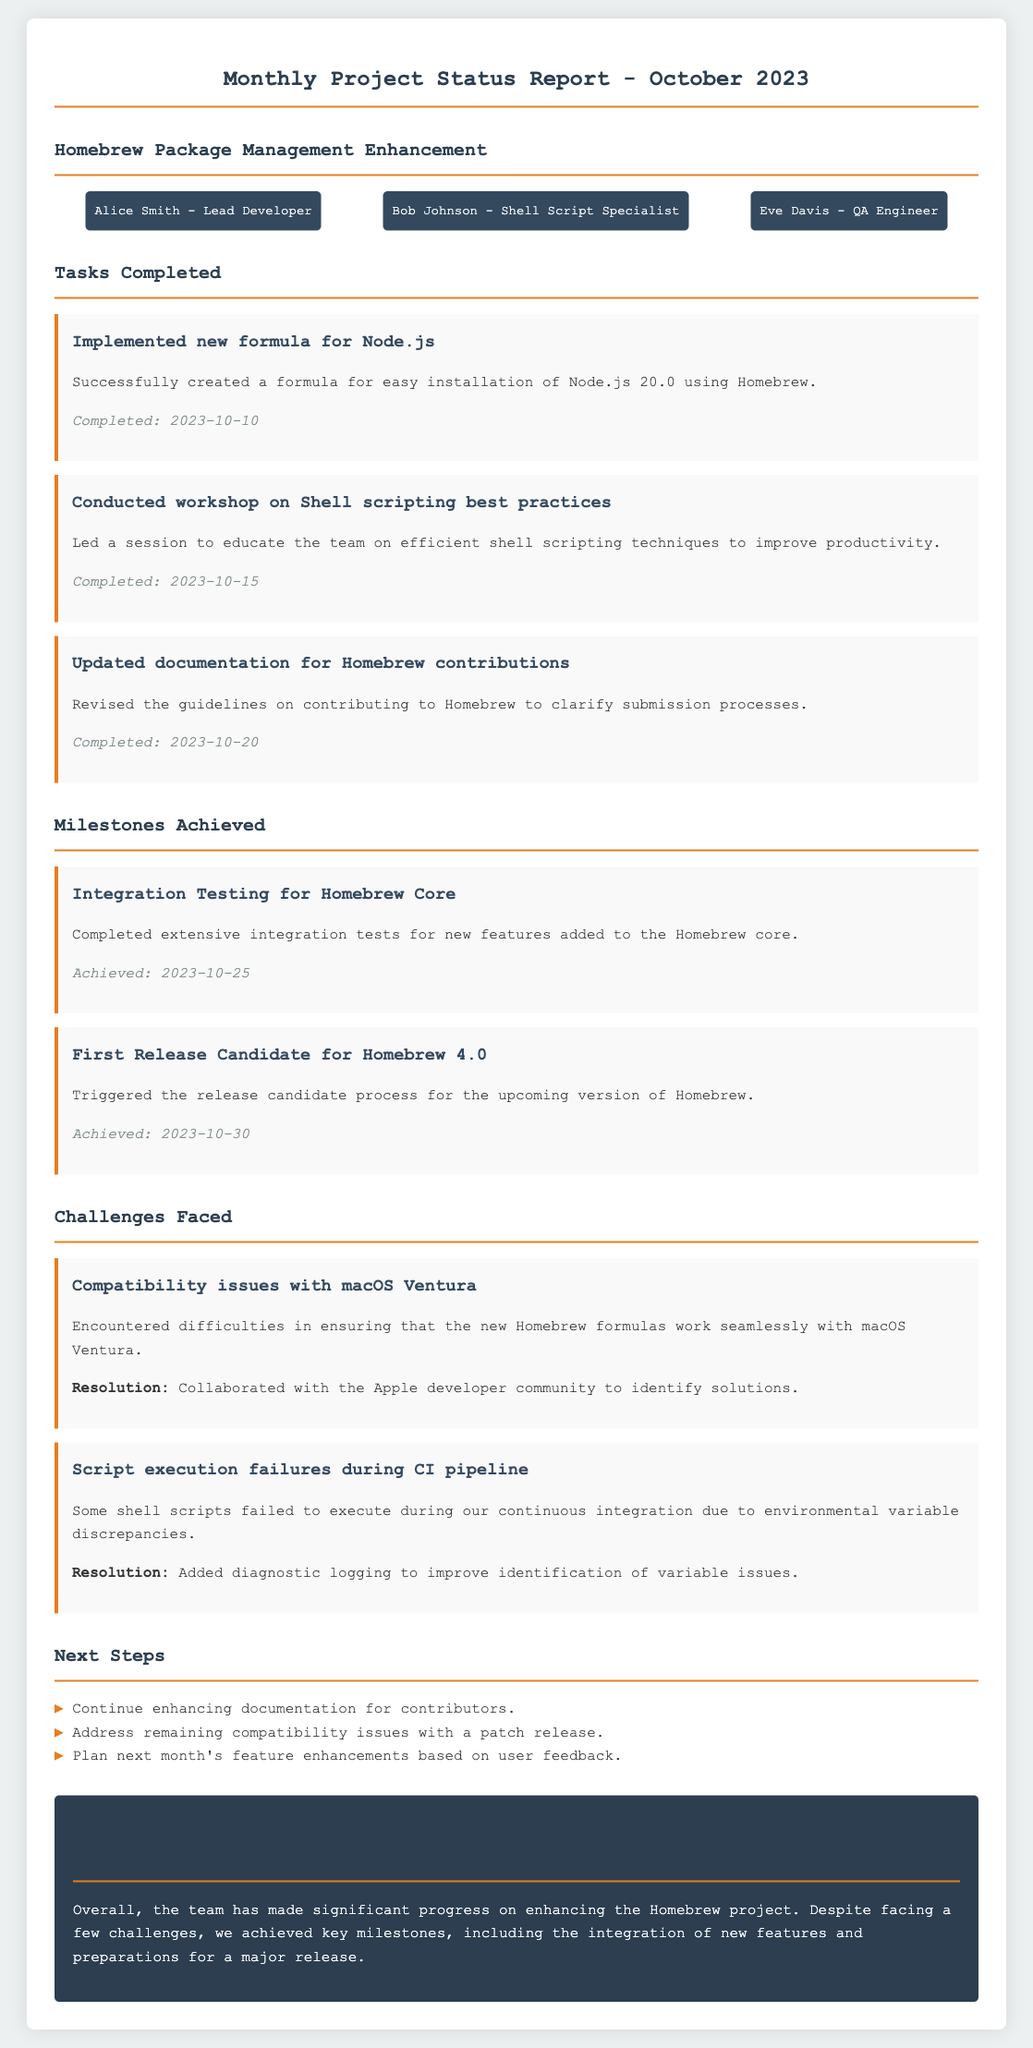What is the title of the report? The title of the report is indicated in the main heading of the document.
Answer: Monthly Project Status Report - October 2023 Who is the lead developer? The lead developer is identified among the team members listed in the document.
Answer: Alice Smith When was the Node.js formula completed? The completion date is provided below the task description for the Node.js formula implementation.
Answer: 2023-10-10 What milestone was achieved on 2023-10-30? The achieved milestone is stated in the milestones section with a specific date.
Answer: First Release Candidate for Homebrew 4.0 What was one of the challenges faced? The challenges faced are listed in the challenges section of the document.
Answer: Compatibility issues with macOS Ventura How many tasks were completed in October 2023? The total number of completed tasks can be counted from the tasks completed section.
Answer: 3 What is the focus of the next steps? The next steps are listed as actionable items at the end of the report.
Answer: Enhance documentation for contributors What type of testing was completed in October? The type of testing is mentioned as a milestone in the milestones section of the document.
Answer: Integration Testing for Homebrew Core What resolution was taken for CI pipeline failures? The resolution for the mentioned challenge is documented after the challenge description.
Answer: Added diagnostic logging to improve identification of variable issues 